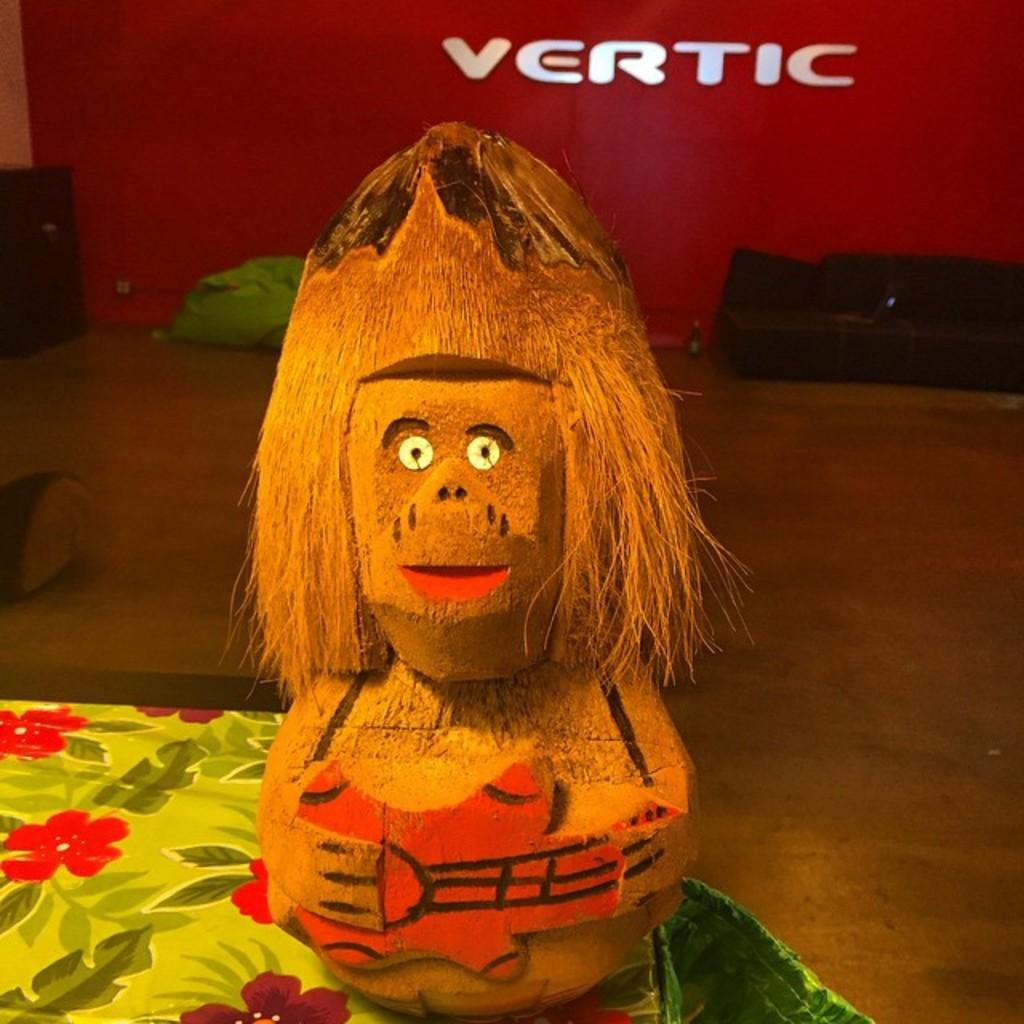What is the main subject of the image? There is a sculpture made of coconuts in the image. What can be seen in the background of the image? There are walls, a polythene bag on the floor, and a mat in the background of the image. What direction is the knife pointing in the image? There is no knife present in the image. How does the sculpture rub against the mat in the image? The sculpture does not rub against the mat in the image; it is stationary. 